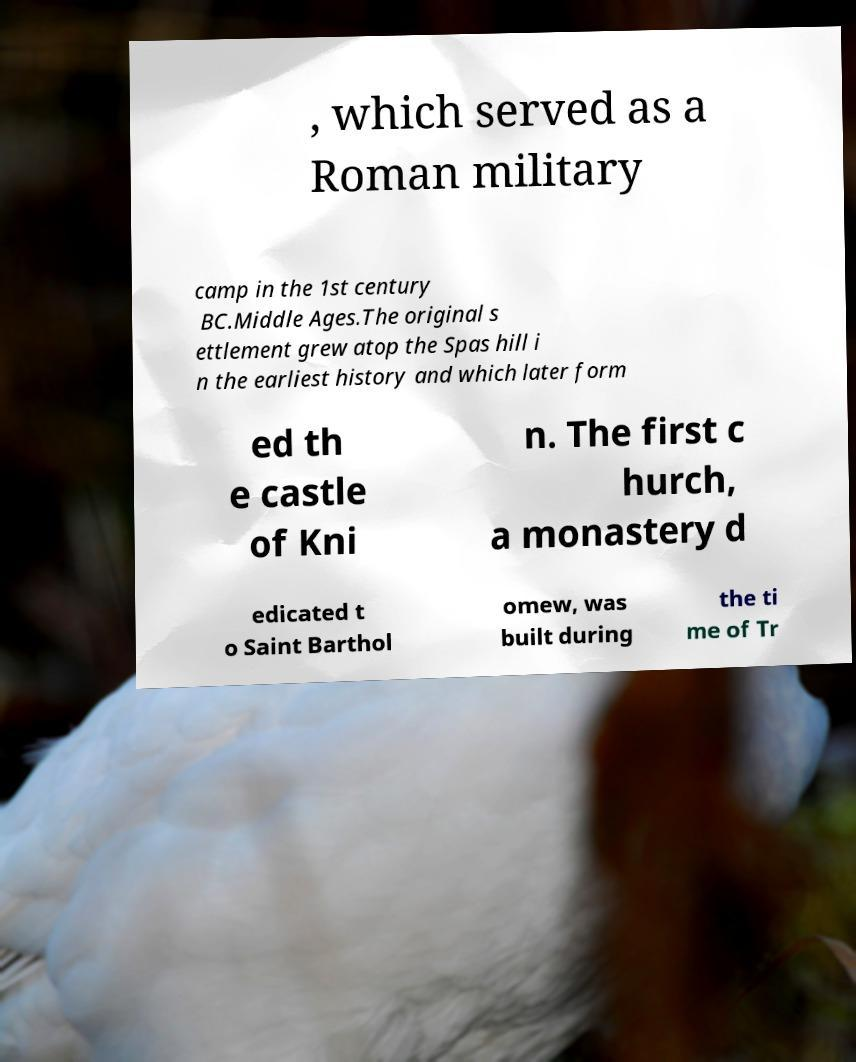I need the written content from this picture converted into text. Can you do that? , which served as a Roman military camp in the 1st century BC.Middle Ages.The original s ettlement grew atop the Spas hill i n the earliest history and which later form ed th e castle of Kni n. The first c hurch, a monastery d edicated t o Saint Barthol omew, was built during the ti me of Tr 